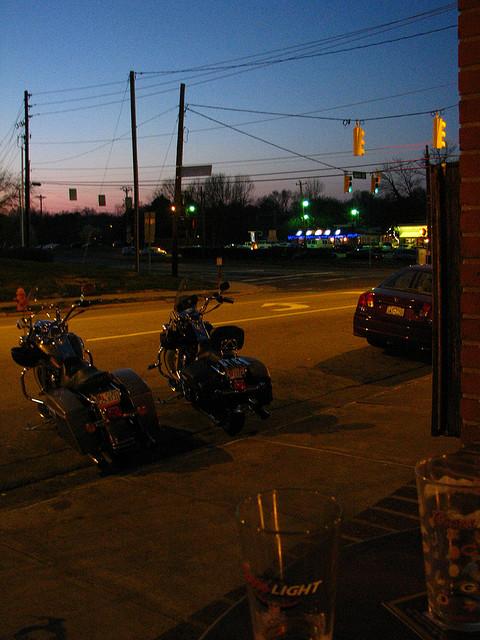What time of the day is it?
Write a very short answer. Night. Is this at a bar?
Write a very short answer. Yes. What company is on the glass?
Short answer required. Coors. 